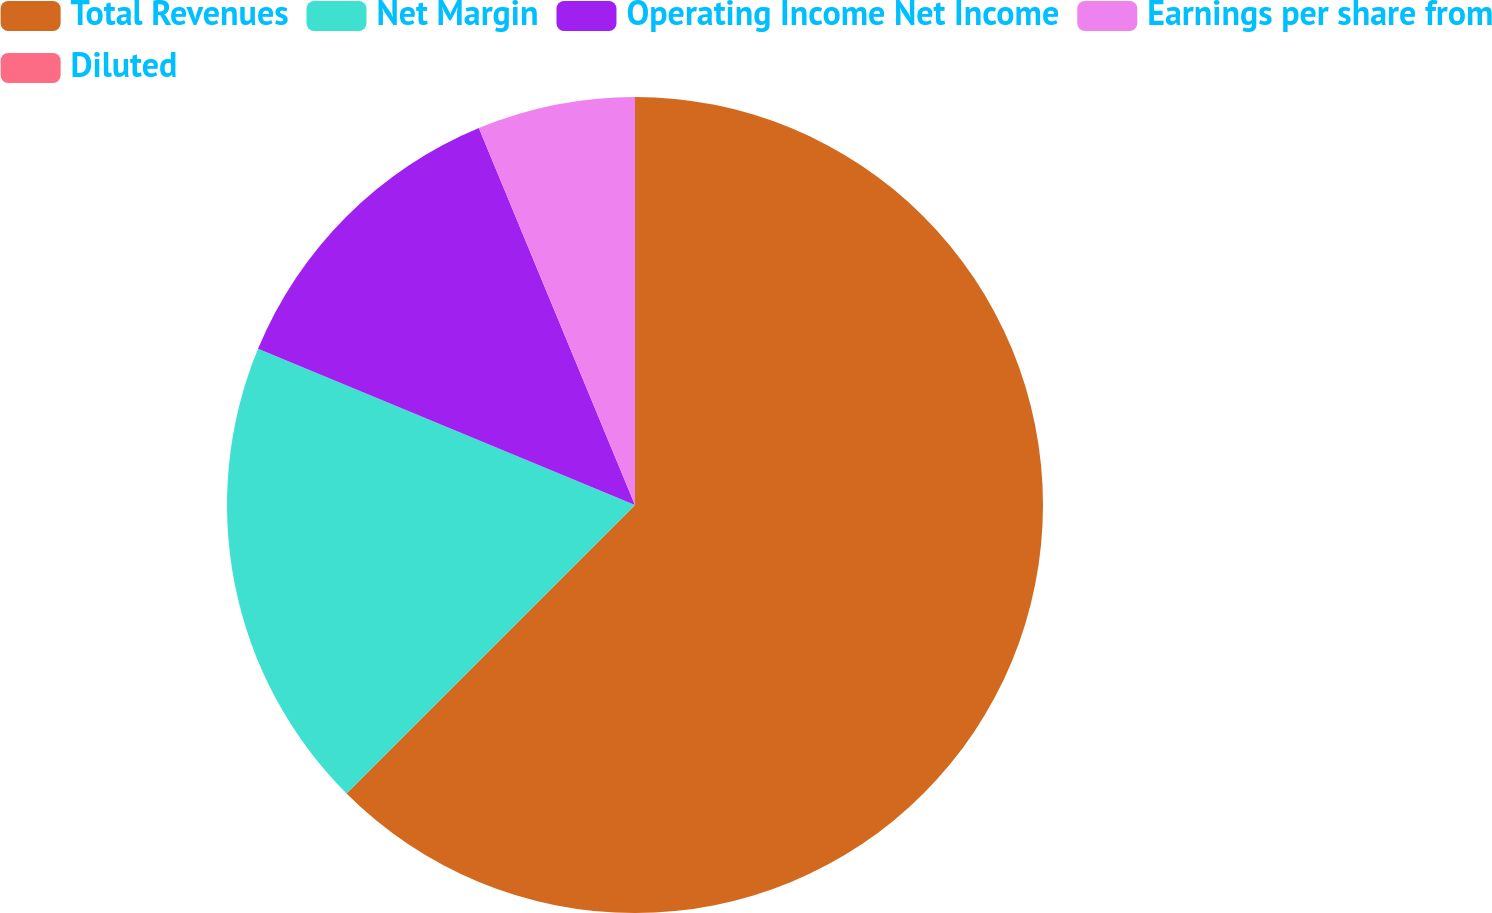Convert chart. <chart><loc_0><loc_0><loc_500><loc_500><pie_chart><fcel>Total Revenues<fcel>Net Margin<fcel>Operating Income Net Income<fcel>Earnings per share from<fcel>Diluted<nl><fcel>62.5%<fcel>18.75%<fcel>12.5%<fcel>6.25%<fcel>0.0%<nl></chart> 